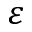Convert formula to latex. <formula><loc_0><loc_0><loc_500><loc_500>\varepsilon</formula> 